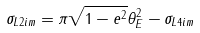<formula> <loc_0><loc_0><loc_500><loc_500>\sigma _ { L 2 i m } = \pi \sqrt { 1 - e ^ { 2 } } \theta _ { E } ^ { 2 } - \sigma _ { L 4 i m }</formula> 